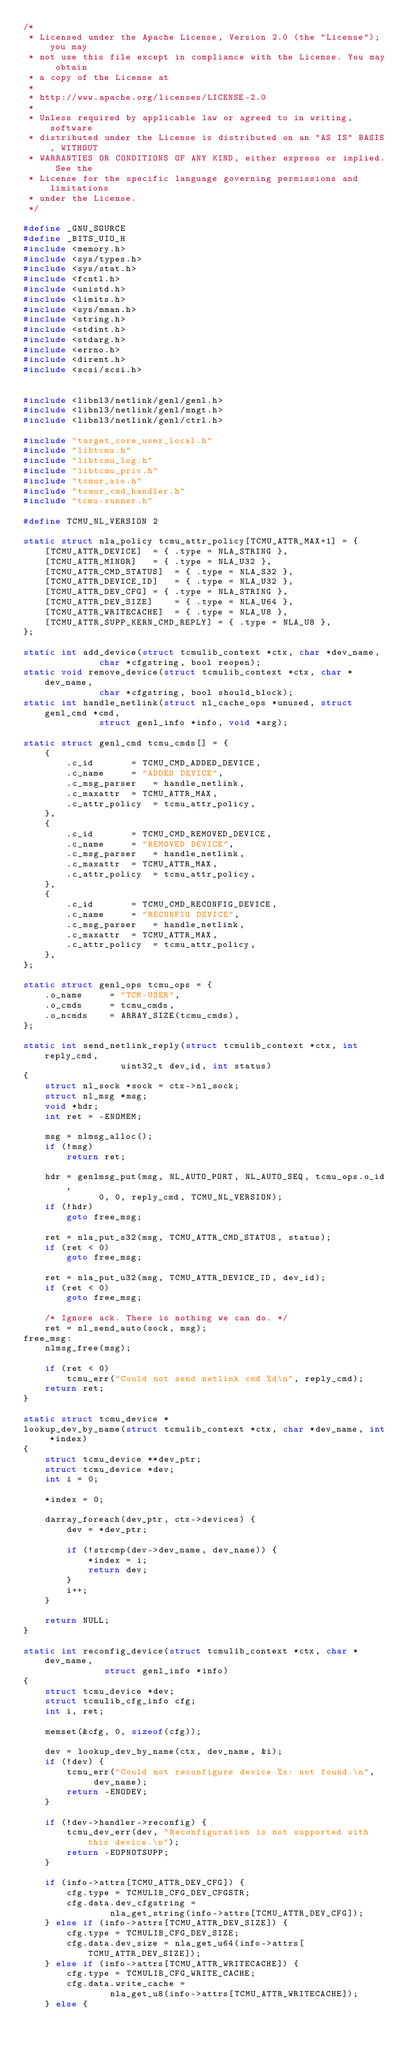<code> <loc_0><loc_0><loc_500><loc_500><_C_>/*
 * Licensed under the Apache License, Version 2.0 (the "License"); you may
 * not use this file except in compliance with the License. You may obtain
 * a copy of the License at
 *
 * http://www.apache.org/licenses/LICENSE-2.0
 *
 * Unless required by applicable law or agreed to in writing, software
 * distributed under the License is distributed on an "AS IS" BASIS, WITHOUT
 * WARRANTIES OR CONDITIONS OF ANY KIND, either express or implied. See the
 * License for the specific language governing permissions and limitations
 * under the License.
 */

#define _GNU_SOURCE
#define _BITS_UIO_H
#include <memory.h>
#include <sys/types.h>
#include <sys/stat.h>
#include <fcntl.h>
#include <unistd.h>
#include <limits.h>
#include <sys/mman.h>
#include <string.h>
#include <stdint.h>
#include <stdarg.h>
#include <errno.h>
#include <dirent.h>
#include <scsi/scsi.h>


#include <libnl3/netlink/genl/genl.h>
#include <libnl3/netlink/genl/mngt.h>
#include <libnl3/netlink/genl/ctrl.h>

#include "target_core_user_local.h"
#include "libtcmu.h"
#include "libtcmu_log.h"
#include "libtcmu_priv.h"
#include "tcmur_aio.h"
#include "tcmur_cmd_handler.h"
#include "tcmu-runner.h"

#define TCMU_NL_VERSION 2

static struct nla_policy tcmu_attr_policy[TCMU_ATTR_MAX+1] = {
	[TCMU_ATTR_DEVICE]	= { .type = NLA_STRING },
	[TCMU_ATTR_MINOR]	= { .type = NLA_U32 },
	[TCMU_ATTR_CMD_STATUS]	= { .type = NLA_S32 },
	[TCMU_ATTR_DEVICE_ID]	= { .type = NLA_U32 },
	[TCMU_ATTR_DEV_CFG]	= { .type = NLA_STRING },
	[TCMU_ATTR_DEV_SIZE]	= { .type = NLA_U64 },
	[TCMU_ATTR_WRITECACHE]	= { .type = NLA_U8 },
	[TCMU_ATTR_SUPP_KERN_CMD_REPLY] = { .type = NLA_U8 },
};

static int add_device(struct tcmulib_context *ctx, char *dev_name,
		      char *cfgstring, bool reopen);
static void remove_device(struct tcmulib_context *ctx, char *dev_name,
			  char *cfgstring, bool should_block);
static int handle_netlink(struct nl_cache_ops *unused, struct genl_cmd *cmd,
			  struct genl_info *info, void *arg);

static struct genl_cmd tcmu_cmds[] = {
	{
		.c_id		= TCMU_CMD_ADDED_DEVICE,
		.c_name		= "ADDED DEVICE",
		.c_msg_parser	= handle_netlink,
		.c_maxattr	= TCMU_ATTR_MAX,
		.c_attr_policy	= tcmu_attr_policy,
	},
	{
		.c_id		= TCMU_CMD_REMOVED_DEVICE,
		.c_name		= "REMOVED DEVICE",
		.c_msg_parser	= handle_netlink,
		.c_maxattr	= TCMU_ATTR_MAX,
		.c_attr_policy	= tcmu_attr_policy,
	},
	{
		.c_id		= TCMU_CMD_RECONFIG_DEVICE,
		.c_name		= "RECONFIG DEVICE",
		.c_msg_parser	= handle_netlink,
		.c_maxattr	= TCMU_ATTR_MAX,
		.c_attr_policy	= tcmu_attr_policy,
	},
};

static struct genl_ops tcmu_ops = {
	.o_name		= "TCM-USER",
	.o_cmds		= tcmu_cmds,
	.o_ncmds	= ARRAY_SIZE(tcmu_cmds),
};

static int send_netlink_reply(struct tcmulib_context *ctx, int reply_cmd,
			      uint32_t dev_id, int status)
{
	struct nl_sock *sock = ctx->nl_sock;
	struct nl_msg *msg;
	void *hdr;
	int ret = -ENOMEM;

	msg = nlmsg_alloc();
	if (!msg)
		return ret;

	hdr = genlmsg_put(msg, NL_AUTO_PORT, NL_AUTO_SEQ, tcmu_ops.o_id,
			  0, 0, reply_cmd, TCMU_NL_VERSION);
	if (!hdr)
		goto free_msg;

	ret = nla_put_s32(msg, TCMU_ATTR_CMD_STATUS, status);
	if (ret < 0)
		goto free_msg;

	ret = nla_put_u32(msg, TCMU_ATTR_DEVICE_ID, dev_id);
	if (ret < 0)
		goto free_msg;

	/* Ignore ack. There is nothing we can do. */
	ret = nl_send_auto(sock, msg);
free_msg:
	nlmsg_free(msg);

	if (ret < 0)
		tcmu_err("Could not send netlink cmd %d\n", reply_cmd);
	return ret;
}

static struct tcmu_device *
lookup_dev_by_name(struct tcmulib_context *ctx, char *dev_name, int *index)
{
	struct tcmu_device **dev_ptr;
	struct tcmu_device *dev;
	int i = 0;

	*index = 0;

	darray_foreach(dev_ptr, ctx->devices) {
		dev = *dev_ptr;

		if (!strcmp(dev->dev_name, dev_name)) {
			*index = i;
			return dev;
		}
		i++;
	}

	return NULL;
}

static int reconfig_device(struct tcmulib_context *ctx, char *dev_name,
			   struct genl_info *info)
{
	struct tcmu_device *dev;
	struct tcmulib_cfg_info cfg;
	int i, ret;

	memset(&cfg, 0, sizeof(cfg));

	dev = lookup_dev_by_name(ctx, dev_name, &i);
	if (!dev) {
		tcmu_err("Could not reconfigure device %s: not found.\n",
			 dev_name);
		return -ENODEV;
	}

	if (!dev->handler->reconfig) {
		tcmu_dev_err(dev, "Reconfiguration is not supported with this device.\n");
		return -EOPNOTSUPP;
	}

	if (info->attrs[TCMU_ATTR_DEV_CFG]) {
		cfg.type = TCMULIB_CFG_DEV_CFGSTR;
		cfg.data.dev_cfgstring =
				nla_get_string(info->attrs[TCMU_ATTR_DEV_CFG]);
	} else if (info->attrs[TCMU_ATTR_DEV_SIZE]) {
		cfg.type = TCMULIB_CFG_DEV_SIZE;
		cfg.data.dev_size = nla_get_u64(info->attrs[TCMU_ATTR_DEV_SIZE]);
	} else if (info->attrs[TCMU_ATTR_WRITECACHE]) {
		cfg.type = TCMULIB_CFG_WRITE_CACHE;
		cfg.data.write_cache =
				nla_get_u8(info->attrs[TCMU_ATTR_WRITECACHE]);
	} else {</code> 